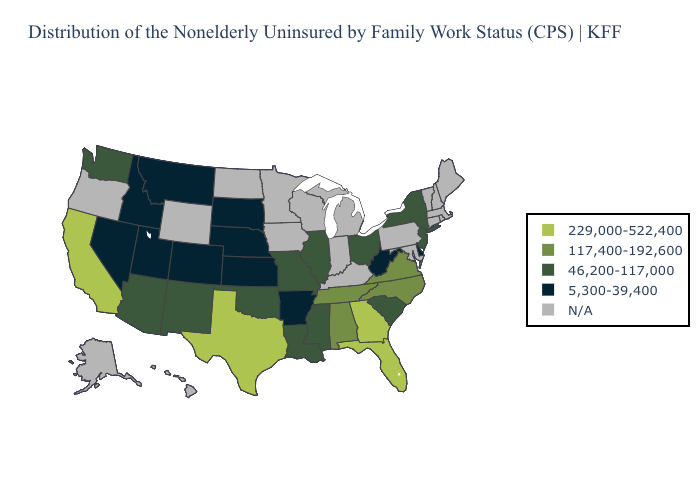What is the value of Mississippi?
Short answer required. 46,200-117,000. What is the value of Minnesota?
Concise answer only. N/A. Does the map have missing data?
Answer briefly. Yes. Name the states that have a value in the range 117,400-192,600?
Answer briefly. Alabama, North Carolina, Tennessee, Virginia. Among the states that border Maryland , which have the lowest value?
Keep it brief. Delaware, West Virginia. What is the lowest value in the USA?
Quick response, please. 5,300-39,400. What is the lowest value in states that border Kansas?
Short answer required. 5,300-39,400. What is the value of South Carolina?
Give a very brief answer. 46,200-117,000. Among the states that border Virginia , which have the highest value?
Quick response, please. North Carolina, Tennessee. Name the states that have a value in the range N/A?
Give a very brief answer. Alaska, Connecticut, Hawaii, Indiana, Iowa, Kentucky, Maine, Maryland, Massachusetts, Michigan, Minnesota, New Hampshire, North Dakota, Oregon, Pennsylvania, Rhode Island, Vermont, Wisconsin, Wyoming. What is the value of Maryland?
Give a very brief answer. N/A. Name the states that have a value in the range 5,300-39,400?
Answer briefly. Arkansas, Colorado, Delaware, Idaho, Kansas, Montana, Nebraska, Nevada, South Dakota, Utah, West Virginia. Which states have the lowest value in the West?
Be succinct. Colorado, Idaho, Montana, Nevada, Utah. Name the states that have a value in the range N/A?
Concise answer only. Alaska, Connecticut, Hawaii, Indiana, Iowa, Kentucky, Maine, Maryland, Massachusetts, Michigan, Minnesota, New Hampshire, North Dakota, Oregon, Pennsylvania, Rhode Island, Vermont, Wisconsin, Wyoming. Which states have the highest value in the USA?
Write a very short answer. California, Florida, Georgia, Texas. 